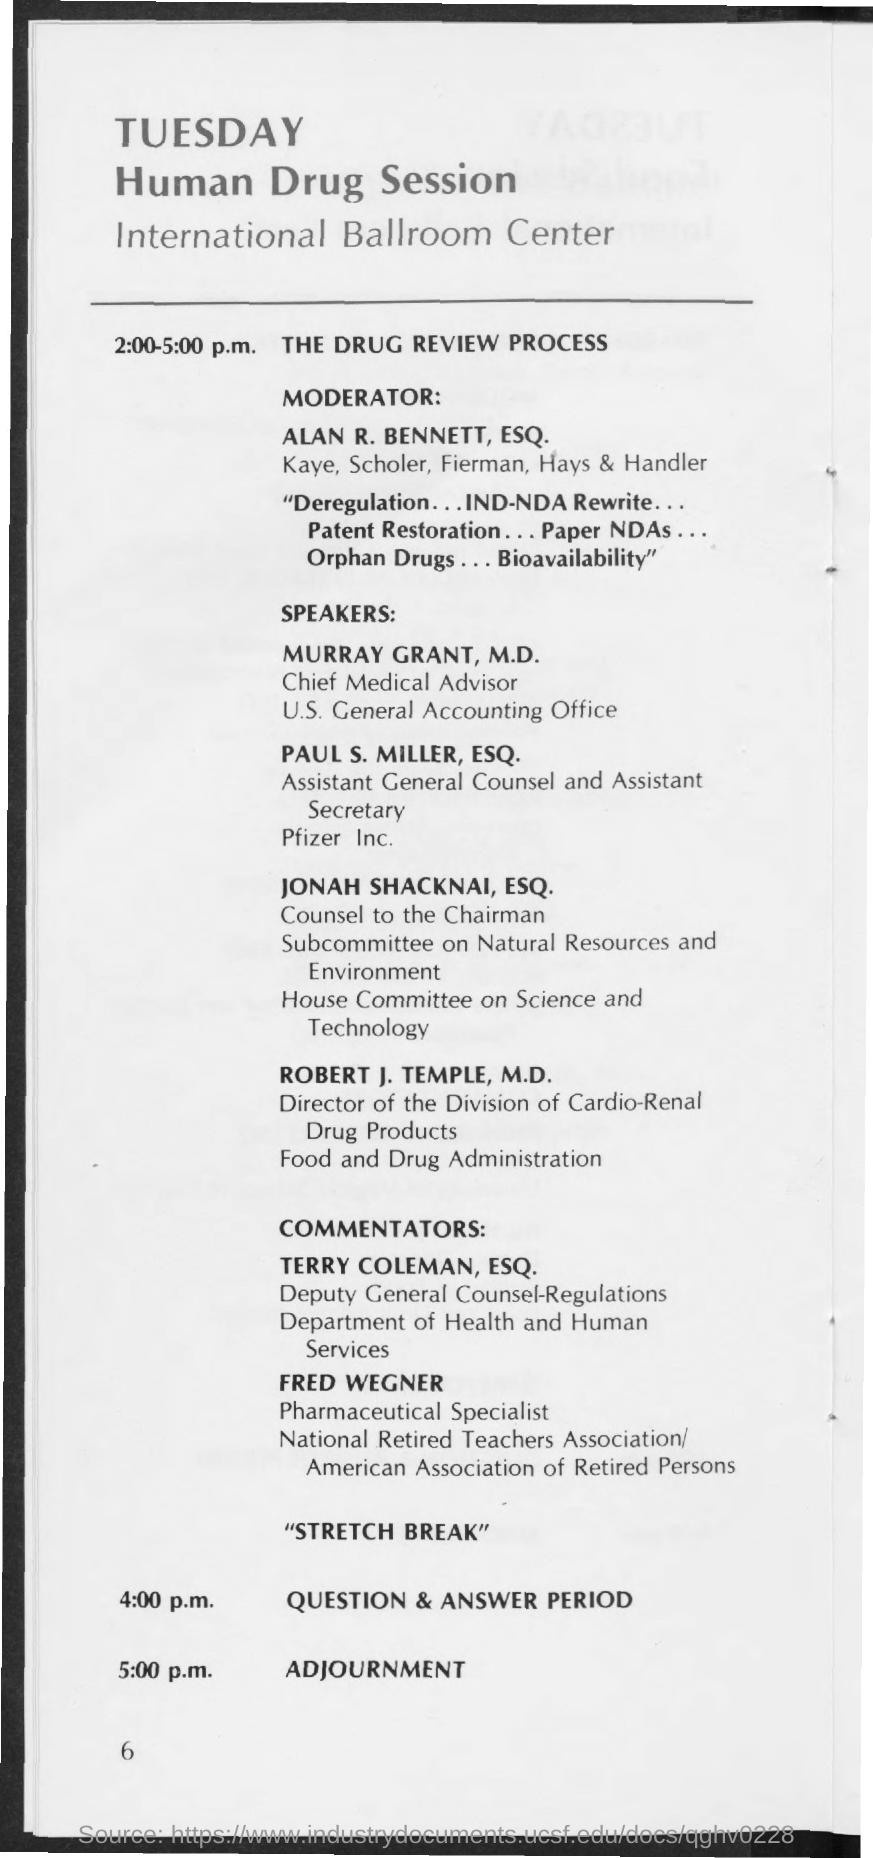'Who is the moderator of Human Drug Session?'
Make the answer very short. ALAN R. BENNETT, ESQ. What is the topic scheduled from '2:00-5:00 p.m.' ?
Make the answer very short. THE DRUG REVIEW PROCESS. Which day of the week is the Human Drug Session Scheduled ?
Offer a very short reply. TUESDAY. 